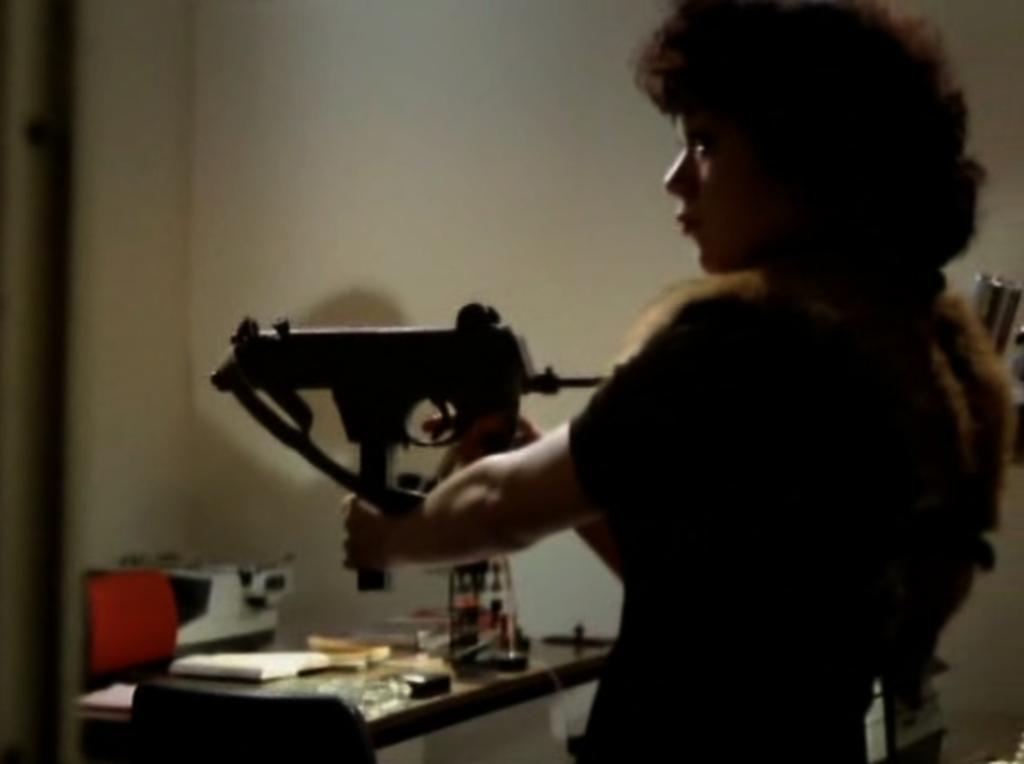How would you summarize this image in a sentence or two? In this picture we can see a person holding an object. Behind the person, there are some objects and a table. At the top of the image, there is a wall. 